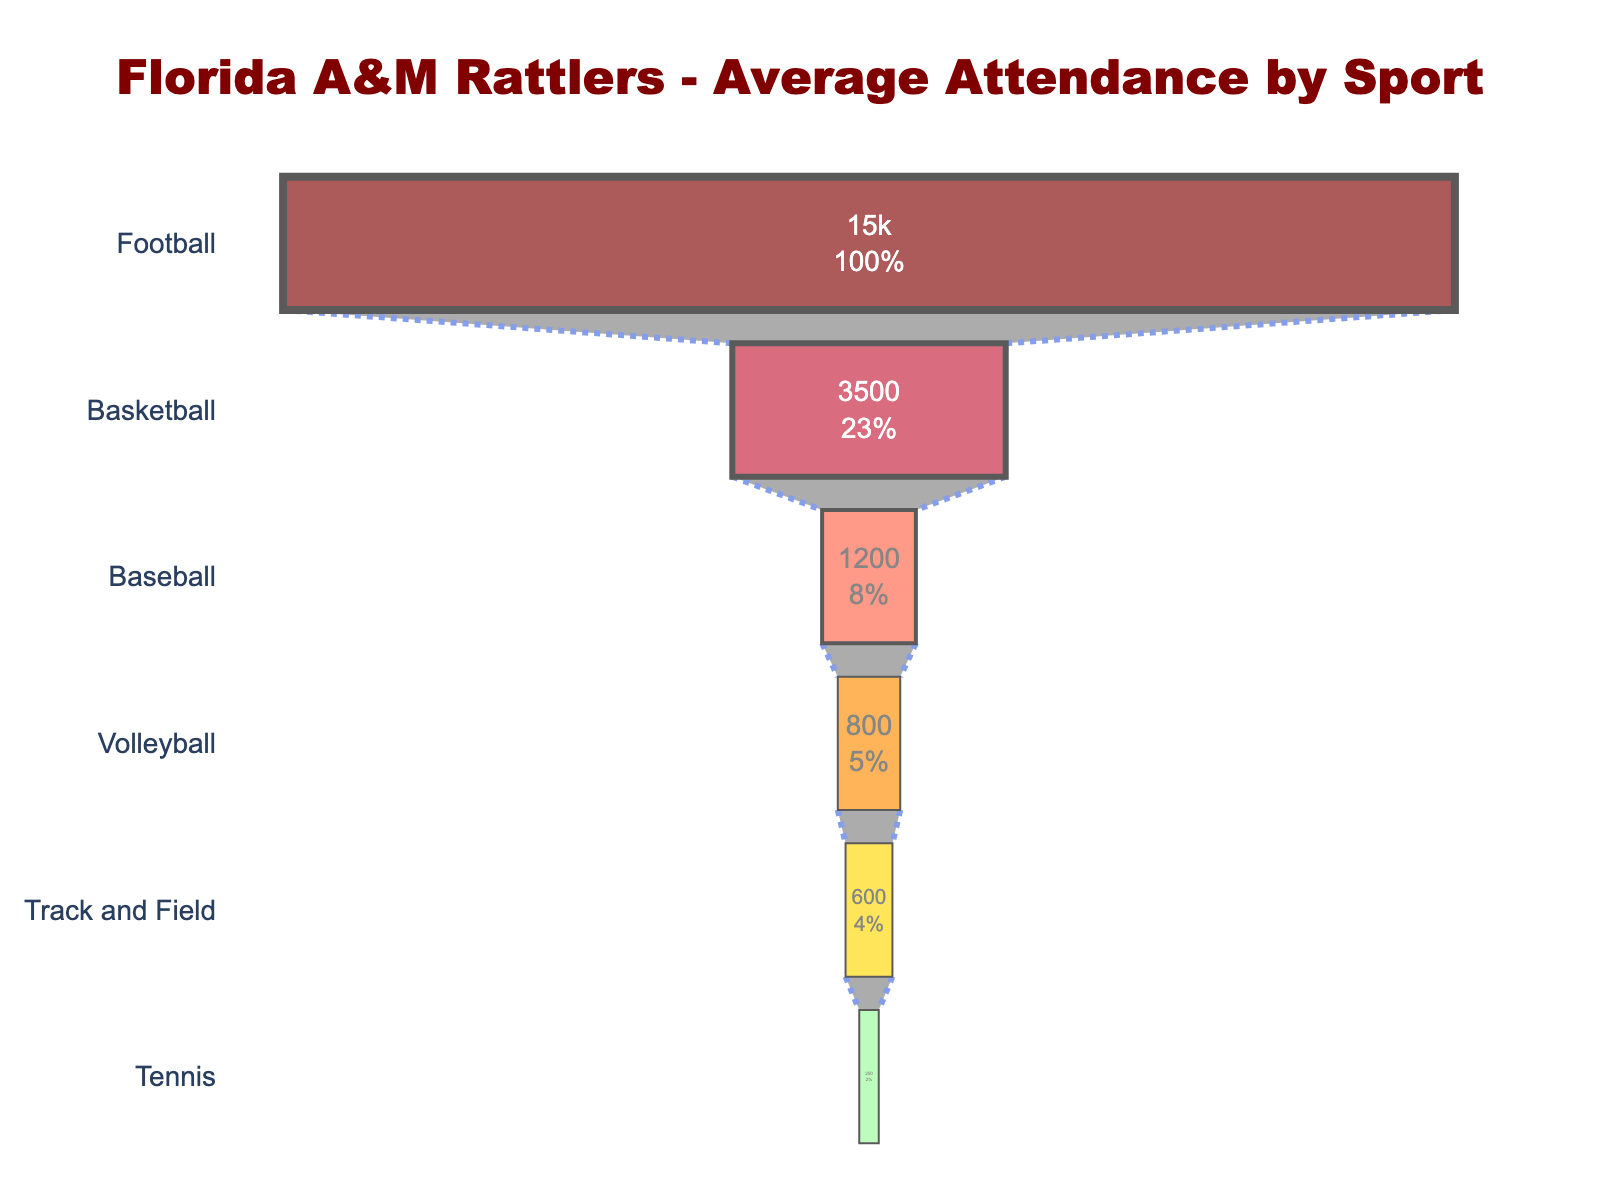How many sports are illustrated in the chart? Count the number of sports names listed in the funnel chart.
Answer: Six Which sport has the highest average attendance? Identify the sport at the widest part of the funnel, which indicates the highest value.
Answer: Football What is the average attendance for volleyball? Locate the segment labeled "Volleyball" and read the attendance figure.
Answer: 800 How much higher is the average attendance for basketball compared to baseball? Subtract the average attendance of baseball from the average attendance of basketball. 3500 - 1200 = 2300
Answer: 2300 What proportion of the total initial attendance does football represent? Compare the football attendance to the sum of all sports attendances. Football: 15000, Total: 15000 + 3500 + 1200 + 800 + 600 + 250 = 21350, Proportion: 15000 / 21350 ≈ 0.702
Answer: Approximately 70.2% Which sport has the smallest average attendance, and what is that value? Identify the sport at the narrowest part of the funnel, which indicates the smallest value.
Answer: Tennis, 250 How much less is the average attendance for track and field compared to volleyball? Subtract the average attendance of track and field from volleyball. 800 - 600 = 200
Answer: 200 What percentage of the initial total attendance does the basketball attendance represent? Percentage = (Basketball attendance / Total attendance) * 100. 3500 / 21350 * 100 ≈ 16.4%
Answer: Approximately 16.4% Which sports have an average attendance greater than 1000? Identify the sports with attendance values over 1000 from the funnel chart.
Answer: Football, Basketball, Baseball 